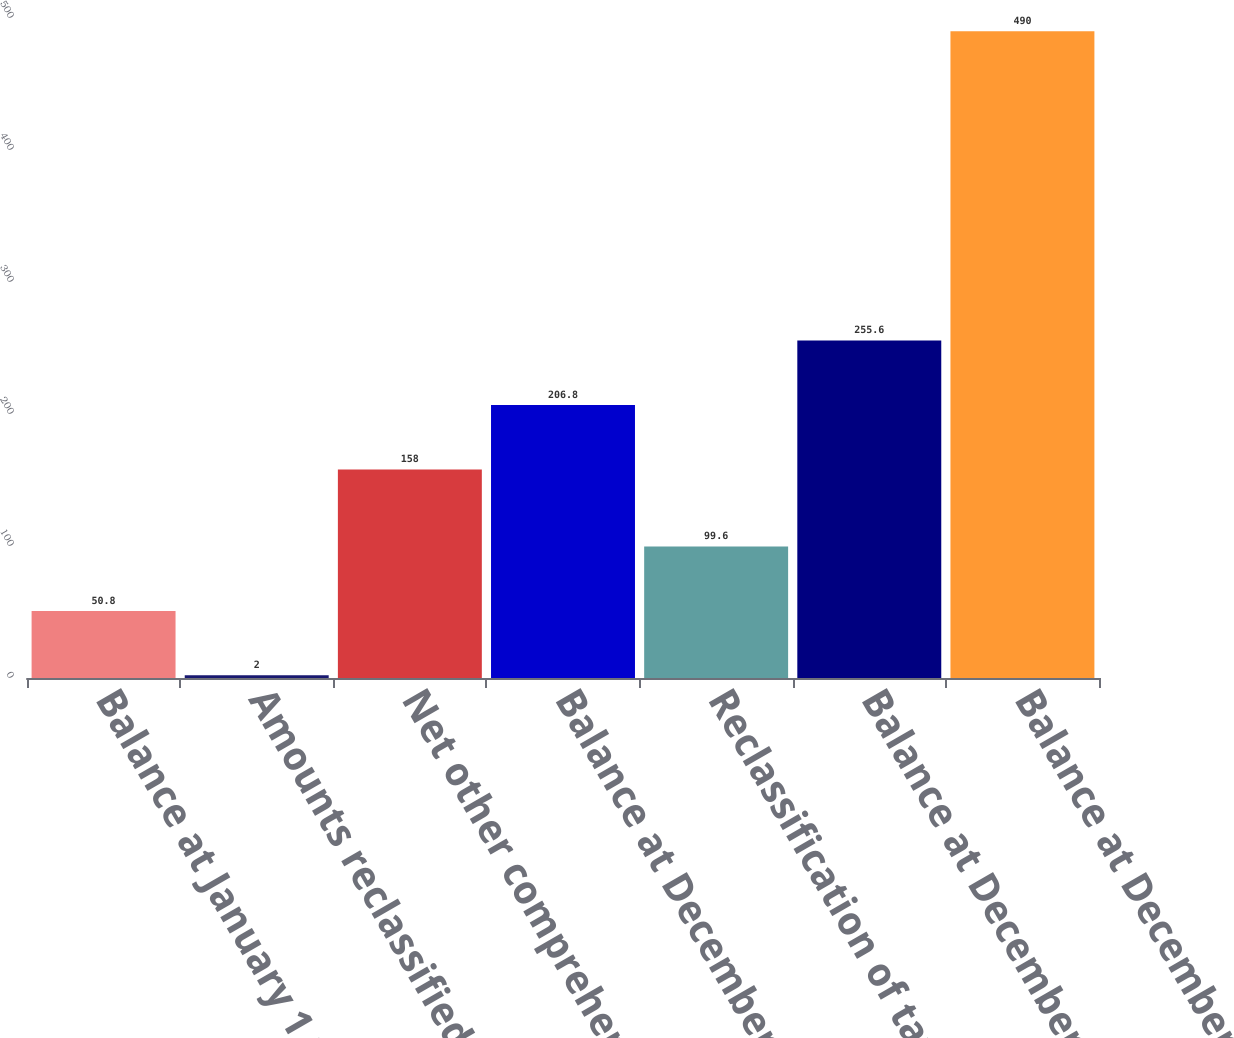Convert chart. <chart><loc_0><loc_0><loc_500><loc_500><bar_chart><fcel>Balance at January 1 2016<fcel>Amounts reclassified to the<fcel>Net other comprehensive loss<fcel>Balance at December 31 2016<fcel>Reclassification of tax<fcel>Balance at December 31 2017<fcel>Balance at December 31 2018<nl><fcel>50.8<fcel>2<fcel>158<fcel>206.8<fcel>99.6<fcel>255.6<fcel>490<nl></chart> 